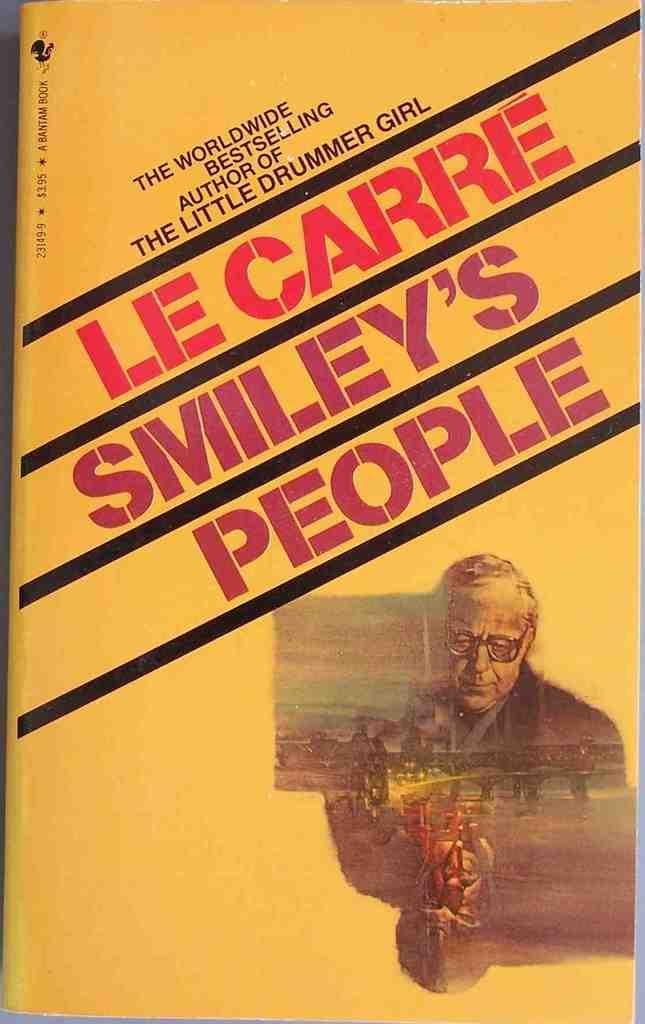Provide a one-sentence caption for the provided image. A book published by Bantam has an old man on the cover. 